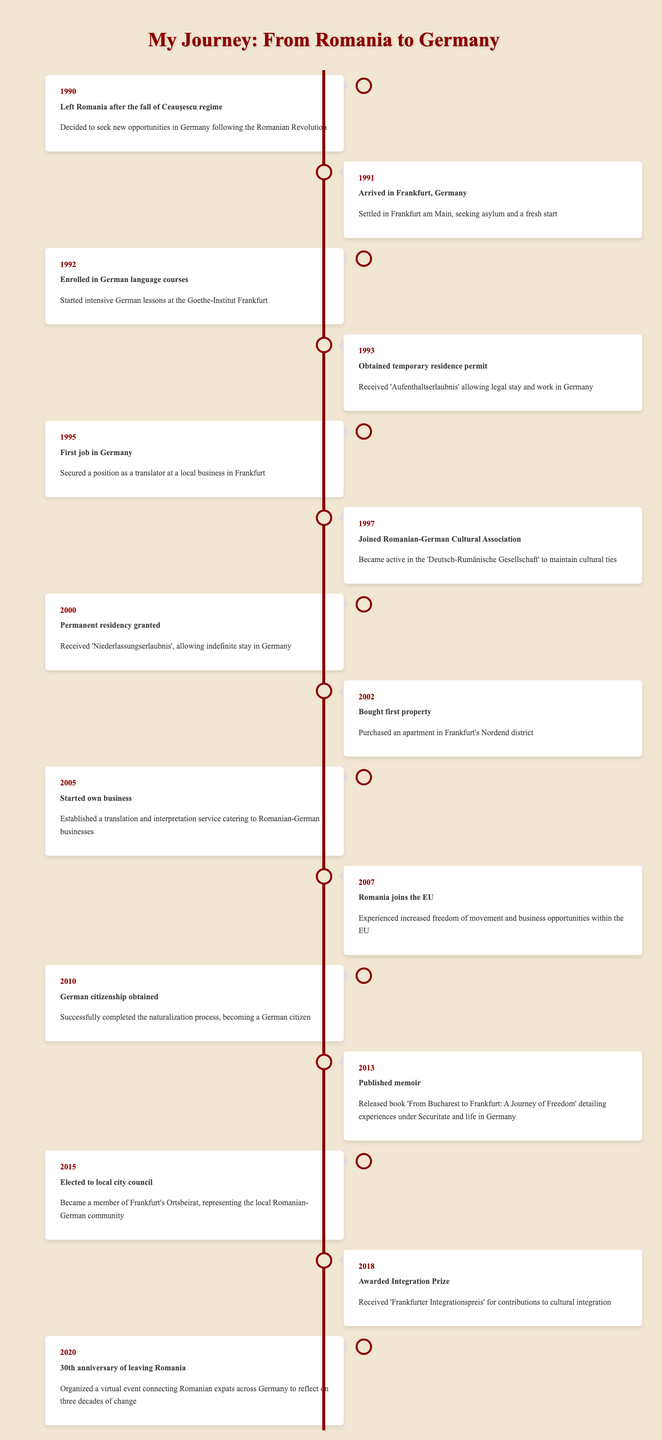What year did you first arrive in Germany? The table indicates that the event "Arrived in Frankfurt, Germany" occurred in 1991. Therefore, I first arrived in Germany that year.
Answer: 1991 What event occurred in 1995? Looking at the timeline, the event listed for 1995 is "First job in Germany." This indicates that I secured my first job that year.
Answer: First job in Germany How many years passed from obtaining a temporary residence permit to receiving permanent residency? The temporary residence permit was obtained in 1993, and permanent residency was granted in 2000. The difference is 2000 - 1993 = 7 years. Therefore, 7 years passed between these two events.
Answer: 7 years Did I publish a memoir before obtaining German citizenship? According to the timeline, the memoir was published in 2013 while German citizenship was obtained in 2010. Since 2013 is after 2010, the statement is false.
Answer: No What significant change for Romanians in Germany occurred in 2007? The event listed for 2007 is "Romania joins the EU," which denotes an important milestone. It signifies that Romanians in Germany experienced increased freedom of movement and business opportunities due to Romania's EU membership.
Answer: Romania joins the EU What is the total number of years from leaving Romania to the 30th anniversary of that departure? The departure from Romania took place in 1990 and the 30th anniversary occurred in 2020. To find the total years, subtract the two years: 2020 - 1990 = 30 years. Thus, there were 30 years from leaving Romania to the anniversary.
Answer: 30 years In what year did I start my own business? The timeline states that the event "Started own business" happened in 2005. This indicates that the year I began my own business was 2005.
Answer: 2005 Was the first job secured before I bought my first property? Looking at the timeline, the first job was secured in 1995, while the first property was bought in 2002. Since 1995 is before 2002, the statement is true.
Answer: Yes 